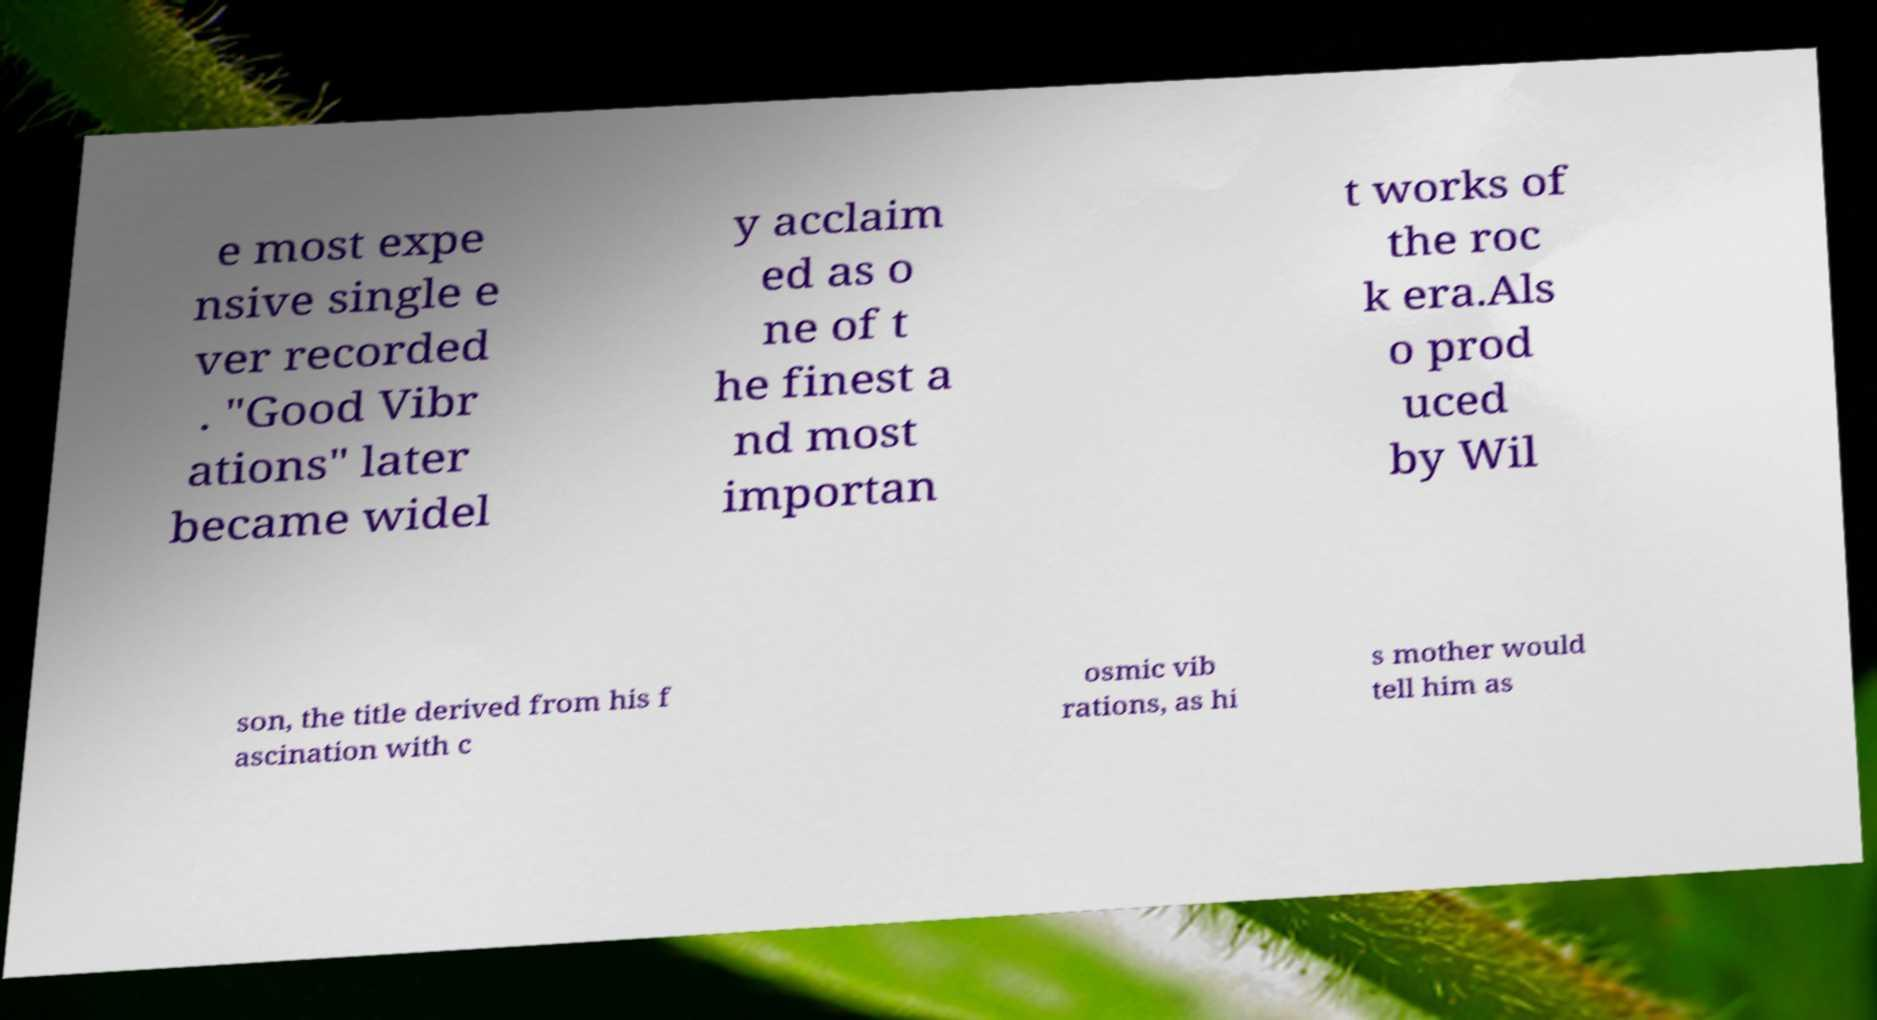There's text embedded in this image that I need extracted. Can you transcribe it verbatim? e most expe nsive single e ver recorded . "Good Vibr ations" later became widel y acclaim ed as o ne of t he finest a nd most importan t works of the roc k era.Als o prod uced by Wil son, the title derived from his f ascination with c osmic vib rations, as hi s mother would tell him as 